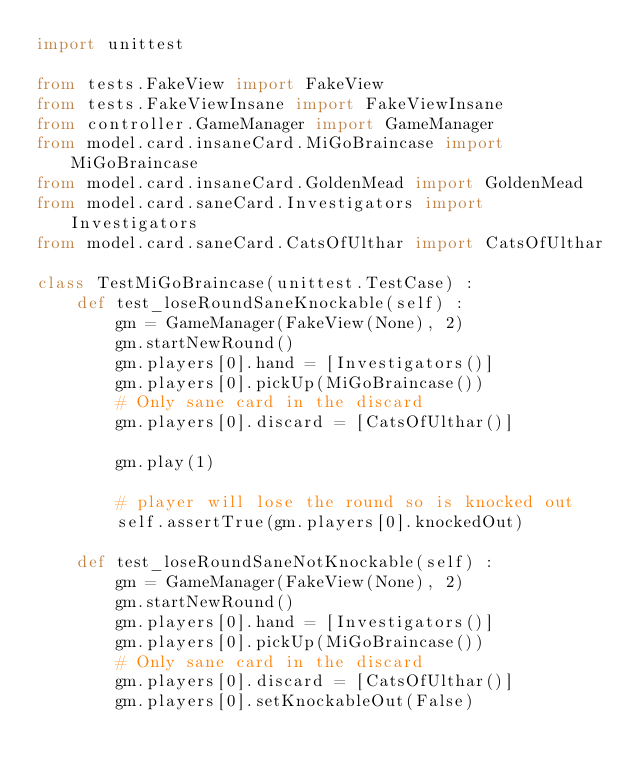Convert code to text. <code><loc_0><loc_0><loc_500><loc_500><_Python_>import unittest

from tests.FakeView import FakeView
from tests.FakeViewInsane import FakeViewInsane
from controller.GameManager import GameManager
from model.card.insaneCard.MiGoBraincase import MiGoBraincase
from model.card.insaneCard.GoldenMead import GoldenMead
from model.card.saneCard.Investigators import Investigators
from model.card.saneCard.CatsOfUlthar import CatsOfUlthar

class TestMiGoBraincase(unittest.TestCase) :
    def test_loseRoundSaneKnockable(self) :
        gm = GameManager(FakeView(None), 2)
        gm.startNewRound()
        gm.players[0].hand = [Investigators()]
        gm.players[0].pickUp(MiGoBraincase())
        # Only sane card in the discard
        gm.players[0].discard = [CatsOfUlthar()]

        gm.play(1)

        # player will lose the round so is knocked out
        self.assertTrue(gm.players[0].knockedOut)

    def test_loseRoundSaneNotKnockable(self) :
        gm = GameManager(FakeView(None), 2)
        gm.startNewRound()
        gm.players[0].hand = [Investigators()]
        gm.players[0].pickUp(MiGoBraincase())
        # Only sane card in the discard
        gm.players[0].discard = [CatsOfUlthar()]
        gm.players[0].setKnockableOut(False)
</code> 